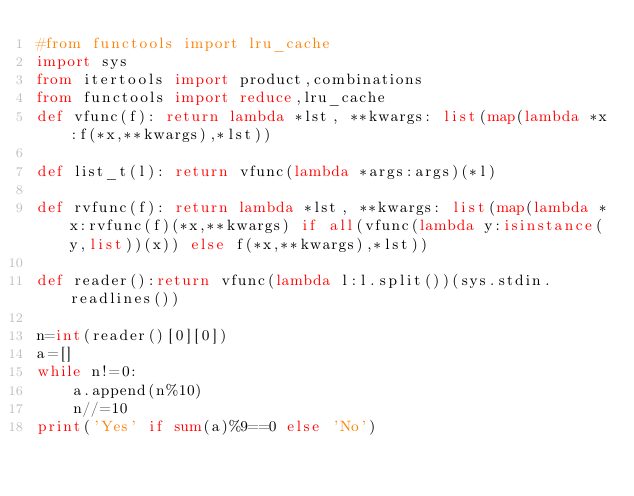<code> <loc_0><loc_0><loc_500><loc_500><_Python_>#from functools import lru_cache
import sys
from itertools import product,combinations
from functools import reduce,lru_cache
def vfunc(f): return lambda *lst, **kwargs: list(map(lambda *x:f(*x,**kwargs),*lst))

def list_t(l): return vfunc(lambda *args:args)(*l)

def rvfunc(f): return lambda *lst, **kwargs: list(map(lambda *x:rvfunc(f)(*x,**kwargs) if all(vfunc(lambda y:isinstance(y,list))(x)) else f(*x,**kwargs),*lst))

def reader():return vfunc(lambda l:l.split())(sys.stdin.readlines())

n=int(reader()[0][0])
a=[]
while n!=0:
    a.append(n%10)
    n//=10
print('Yes' if sum(a)%9==0 else 'No')</code> 